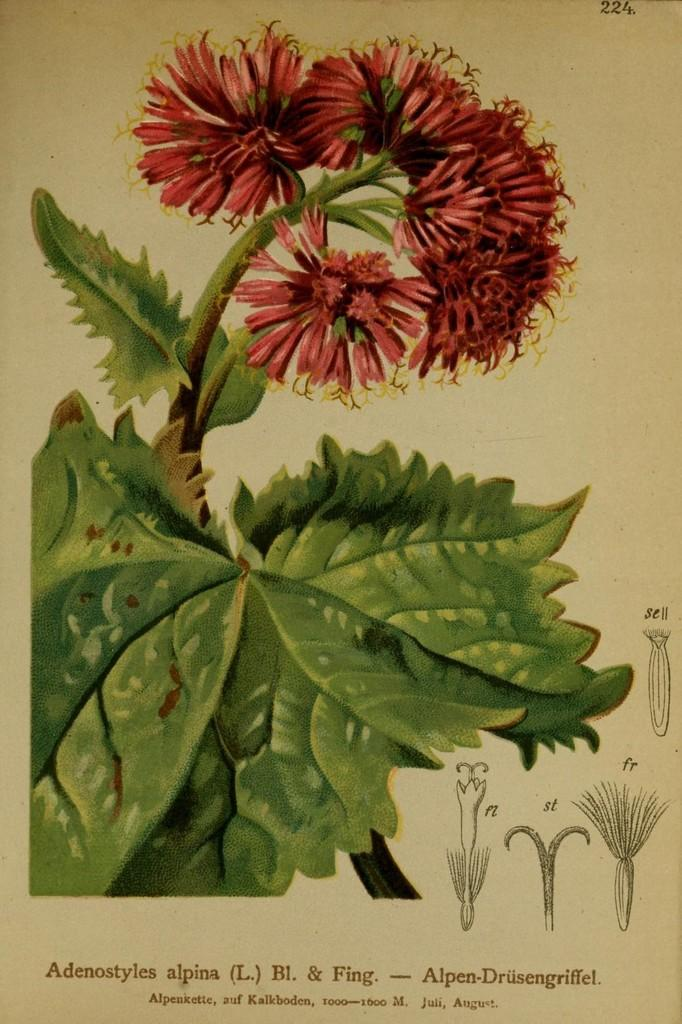What is the main subject of the poster in the image? The main subject of the poster in the image is a flower plant. What else can be seen on the poster besides the flower plant? The poster includes images of flower parts. Is there any text on the poster? Yes, there is text written on the poster. What type of pie is being served on the poster? There is no pie present on the poster; it features an image of a flower plant and flower parts. Can you tell me where the lamp is located on the poster? There is no lamp present on the poster. 